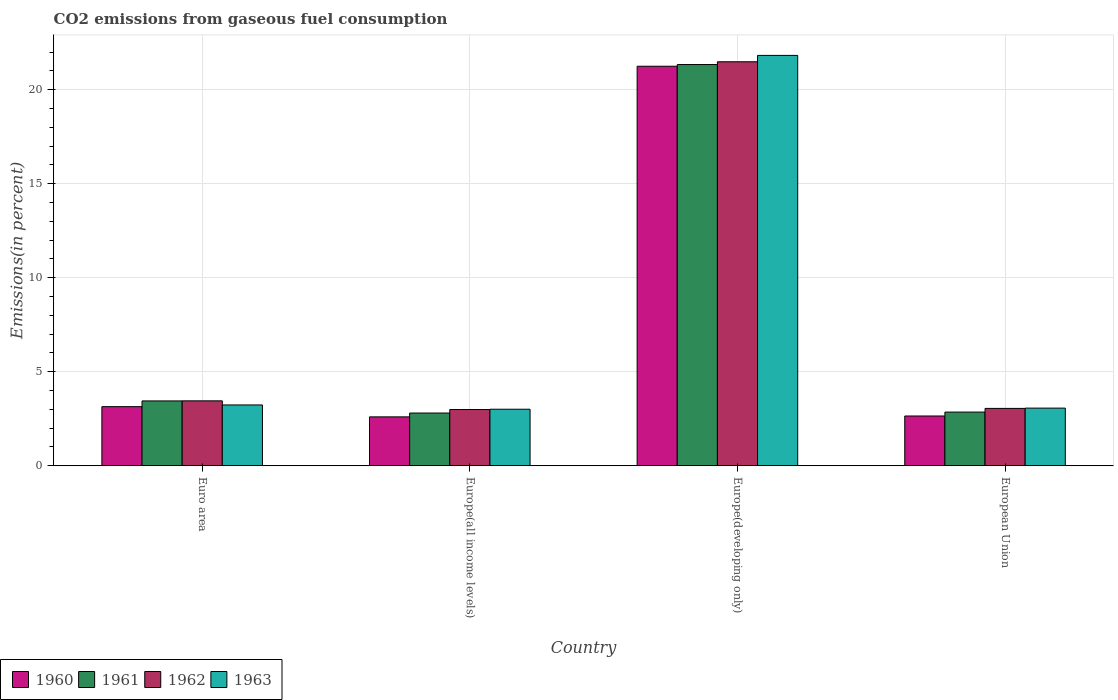Are the number of bars per tick equal to the number of legend labels?
Ensure brevity in your answer.  Yes. What is the label of the 1st group of bars from the left?
Give a very brief answer. Euro area. In how many cases, is the number of bars for a given country not equal to the number of legend labels?
Provide a succinct answer. 0. What is the total CO2 emitted in 1961 in Europe(developing only)?
Your response must be concise. 21.34. Across all countries, what is the maximum total CO2 emitted in 1962?
Provide a short and direct response. 21.49. Across all countries, what is the minimum total CO2 emitted in 1963?
Offer a terse response. 3.01. In which country was the total CO2 emitted in 1963 maximum?
Your answer should be compact. Europe(developing only). In which country was the total CO2 emitted in 1960 minimum?
Your answer should be very brief. Europe(all income levels). What is the total total CO2 emitted in 1962 in the graph?
Your response must be concise. 30.98. What is the difference between the total CO2 emitted in 1962 in Europe(developing only) and that in European Union?
Keep it short and to the point. 18.44. What is the difference between the total CO2 emitted in 1963 in Europe(developing only) and the total CO2 emitted in 1960 in Europe(all income levels)?
Your response must be concise. 19.23. What is the average total CO2 emitted in 1963 per country?
Give a very brief answer. 7.78. What is the difference between the total CO2 emitted of/in 1960 and total CO2 emitted of/in 1963 in Europe(all income levels)?
Ensure brevity in your answer.  -0.41. What is the ratio of the total CO2 emitted in 1963 in Europe(developing only) to that in European Union?
Provide a short and direct response. 7.12. Is the difference between the total CO2 emitted in 1960 in Europe(all income levels) and Europe(developing only) greater than the difference between the total CO2 emitted in 1963 in Europe(all income levels) and Europe(developing only)?
Offer a terse response. Yes. What is the difference between the highest and the second highest total CO2 emitted in 1961?
Give a very brief answer. -0.59. What is the difference between the highest and the lowest total CO2 emitted in 1961?
Keep it short and to the point. 18.54. In how many countries, is the total CO2 emitted in 1960 greater than the average total CO2 emitted in 1960 taken over all countries?
Give a very brief answer. 1. What does the 2nd bar from the right in Europe(all income levels) represents?
Provide a succinct answer. 1962. Does the graph contain any zero values?
Ensure brevity in your answer.  No. Does the graph contain grids?
Your answer should be very brief. Yes. How are the legend labels stacked?
Provide a succinct answer. Horizontal. What is the title of the graph?
Offer a very short reply. CO2 emissions from gaseous fuel consumption. Does "1971" appear as one of the legend labels in the graph?
Keep it short and to the point. No. What is the label or title of the X-axis?
Make the answer very short. Country. What is the label or title of the Y-axis?
Offer a very short reply. Emissions(in percent). What is the Emissions(in percent) of 1960 in Euro area?
Your answer should be very brief. 3.14. What is the Emissions(in percent) in 1961 in Euro area?
Your answer should be very brief. 3.45. What is the Emissions(in percent) of 1962 in Euro area?
Your answer should be very brief. 3.45. What is the Emissions(in percent) of 1963 in Euro area?
Offer a terse response. 3.23. What is the Emissions(in percent) of 1960 in Europe(all income levels)?
Your answer should be very brief. 2.6. What is the Emissions(in percent) in 1961 in Europe(all income levels)?
Offer a very short reply. 2.8. What is the Emissions(in percent) in 1962 in Europe(all income levels)?
Provide a succinct answer. 2.99. What is the Emissions(in percent) of 1963 in Europe(all income levels)?
Keep it short and to the point. 3.01. What is the Emissions(in percent) in 1960 in Europe(developing only)?
Make the answer very short. 21.25. What is the Emissions(in percent) of 1961 in Europe(developing only)?
Give a very brief answer. 21.34. What is the Emissions(in percent) in 1962 in Europe(developing only)?
Your answer should be compact. 21.49. What is the Emissions(in percent) in 1963 in Europe(developing only)?
Your response must be concise. 21.83. What is the Emissions(in percent) of 1960 in European Union?
Give a very brief answer. 2.65. What is the Emissions(in percent) of 1961 in European Union?
Your answer should be compact. 2.85. What is the Emissions(in percent) in 1962 in European Union?
Your response must be concise. 3.05. What is the Emissions(in percent) in 1963 in European Union?
Provide a short and direct response. 3.06. Across all countries, what is the maximum Emissions(in percent) of 1960?
Offer a terse response. 21.25. Across all countries, what is the maximum Emissions(in percent) of 1961?
Offer a terse response. 21.34. Across all countries, what is the maximum Emissions(in percent) in 1962?
Your answer should be very brief. 21.49. Across all countries, what is the maximum Emissions(in percent) of 1963?
Give a very brief answer. 21.83. Across all countries, what is the minimum Emissions(in percent) in 1960?
Your answer should be compact. 2.6. Across all countries, what is the minimum Emissions(in percent) in 1961?
Ensure brevity in your answer.  2.8. Across all countries, what is the minimum Emissions(in percent) of 1962?
Your answer should be very brief. 2.99. Across all countries, what is the minimum Emissions(in percent) in 1963?
Offer a very short reply. 3.01. What is the total Emissions(in percent) in 1960 in the graph?
Offer a very short reply. 29.64. What is the total Emissions(in percent) in 1961 in the graph?
Keep it short and to the point. 30.45. What is the total Emissions(in percent) in 1962 in the graph?
Your response must be concise. 30.98. What is the total Emissions(in percent) of 1963 in the graph?
Offer a terse response. 31.13. What is the difference between the Emissions(in percent) of 1960 in Euro area and that in Europe(all income levels)?
Offer a very short reply. 0.54. What is the difference between the Emissions(in percent) of 1961 in Euro area and that in Europe(all income levels)?
Provide a succinct answer. 0.64. What is the difference between the Emissions(in percent) of 1962 in Euro area and that in Europe(all income levels)?
Your response must be concise. 0.46. What is the difference between the Emissions(in percent) in 1963 in Euro area and that in Europe(all income levels)?
Your response must be concise. 0.23. What is the difference between the Emissions(in percent) of 1960 in Euro area and that in Europe(developing only)?
Your answer should be compact. -18.11. What is the difference between the Emissions(in percent) of 1961 in Euro area and that in Europe(developing only)?
Give a very brief answer. -17.89. What is the difference between the Emissions(in percent) in 1962 in Euro area and that in Europe(developing only)?
Offer a very short reply. -18.04. What is the difference between the Emissions(in percent) in 1963 in Euro area and that in Europe(developing only)?
Offer a very short reply. -18.6. What is the difference between the Emissions(in percent) in 1960 in Euro area and that in European Union?
Offer a very short reply. 0.5. What is the difference between the Emissions(in percent) of 1961 in Euro area and that in European Union?
Your response must be concise. 0.59. What is the difference between the Emissions(in percent) in 1962 in Euro area and that in European Union?
Provide a short and direct response. 0.4. What is the difference between the Emissions(in percent) of 1963 in Euro area and that in European Union?
Offer a very short reply. 0.17. What is the difference between the Emissions(in percent) in 1960 in Europe(all income levels) and that in Europe(developing only)?
Provide a succinct answer. -18.65. What is the difference between the Emissions(in percent) in 1961 in Europe(all income levels) and that in Europe(developing only)?
Provide a short and direct response. -18.54. What is the difference between the Emissions(in percent) of 1962 in Europe(all income levels) and that in Europe(developing only)?
Your answer should be very brief. -18.5. What is the difference between the Emissions(in percent) in 1963 in Europe(all income levels) and that in Europe(developing only)?
Give a very brief answer. -18.82. What is the difference between the Emissions(in percent) of 1960 in Europe(all income levels) and that in European Union?
Provide a short and direct response. -0.05. What is the difference between the Emissions(in percent) in 1961 in Europe(all income levels) and that in European Union?
Give a very brief answer. -0.05. What is the difference between the Emissions(in percent) of 1962 in Europe(all income levels) and that in European Union?
Your answer should be very brief. -0.06. What is the difference between the Emissions(in percent) in 1963 in Europe(all income levels) and that in European Union?
Make the answer very short. -0.06. What is the difference between the Emissions(in percent) in 1960 in Europe(developing only) and that in European Union?
Give a very brief answer. 18.61. What is the difference between the Emissions(in percent) in 1961 in Europe(developing only) and that in European Union?
Offer a terse response. 18.49. What is the difference between the Emissions(in percent) of 1962 in Europe(developing only) and that in European Union?
Provide a short and direct response. 18.44. What is the difference between the Emissions(in percent) of 1963 in Europe(developing only) and that in European Union?
Give a very brief answer. 18.76. What is the difference between the Emissions(in percent) of 1960 in Euro area and the Emissions(in percent) of 1961 in Europe(all income levels)?
Keep it short and to the point. 0.34. What is the difference between the Emissions(in percent) of 1960 in Euro area and the Emissions(in percent) of 1962 in Europe(all income levels)?
Provide a succinct answer. 0.15. What is the difference between the Emissions(in percent) in 1960 in Euro area and the Emissions(in percent) in 1963 in Europe(all income levels)?
Make the answer very short. 0.14. What is the difference between the Emissions(in percent) of 1961 in Euro area and the Emissions(in percent) of 1962 in Europe(all income levels)?
Provide a short and direct response. 0.46. What is the difference between the Emissions(in percent) in 1961 in Euro area and the Emissions(in percent) in 1963 in Europe(all income levels)?
Give a very brief answer. 0.44. What is the difference between the Emissions(in percent) of 1962 in Euro area and the Emissions(in percent) of 1963 in Europe(all income levels)?
Keep it short and to the point. 0.45. What is the difference between the Emissions(in percent) of 1960 in Euro area and the Emissions(in percent) of 1961 in Europe(developing only)?
Your answer should be very brief. -18.2. What is the difference between the Emissions(in percent) of 1960 in Euro area and the Emissions(in percent) of 1962 in Europe(developing only)?
Give a very brief answer. -18.35. What is the difference between the Emissions(in percent) of 1960 in Euro area and the Emissions(in percent) of 1963 in Europe(developing only)?
Make the answer very short. -18.69. What is the difference between the Emissions(in percent) in 1961 in Euro area and the Emissions(in percent) in 1962 in Europe(developing only)?
Give a very brief answer. -18.04. What is the difference between the Emissions(in percent) of 1961 in Euro area and the Emissions(in percent) of 1963 in Europe(developing only)?
Make the answer very short. -18.38. What is the difference between the Emissions(in percent) in 1962 in Euro area and the Emissions(in percent) in 1963 in Europe(developing only)?
Your answer should be very brief. -18.38. What is the difference between the Emissions(in percent) in 1960 in Euro area and the Emissions(in percent) in 1961 in European Union?
Provide a succinct answer. 0.29. What is the difference between the Emissions(in percent) in 1960 in Euro area and the Emissions(in percent) in 1962 in European Union?
Your answer should be compact. 0.09. What is the difference between the Emissions(in percent) of 1960 in Euro area and the Emissions(in percent) of 1963 in European Union?
Your response must be concise. 0.08. What is the difference between the Emissions(in percent) of 1961 in Euro area and the Emissions(in percent) of 1962 in European Union?
Offer a terse response. 0.4. What is the difference between the Emissions(in percent) of 1961 in Euro area and the Emissions(in percent) of 1963 in European Union?
Provide a short and direct response. 0.38. What is the difference between the Emissions(in percent) of 1962 in Euro area and the Emissions(in percent) of 1963 in European Union?
Keep it short and to the point. 0.39. What is the difference between the Emissions(in percent) of 1960 in Europe(all income levels) and the Emissions(in percent) of 1961 in Europe(developing only)?
Give a very brief answer. -18.74. What is the difference between the Emissions(in percent) in 1960 in Europe(all income levels) and the Emissions(in percent) in 1962 in Europe(developing only)?
Keep it short and to the point. -18.89. What is the difference between the Emissions(in percent) in 1960 in Europe(all income levels) and the Emissions(in percent) in 1963 in Europe(developing only)?
Provide a short and direct response. -19.23. What is the difference between the Emissions(in percent) in 1961 in Europe(all income levels) and the Emissions(in percent) in 1962 in Europe(developing only)?
Offer a terse response. -18.69. What is the difference between the Emissions(in percent) of 1961 in Europe(all income levels) and the Emissions(in percent) of 1963 in Europe(developing only)?
Keep it short and to the point. -19.03. What is the difference between the Emissions(in percent) of 1962 in Europe(all income levels) and the Emissions(in percent) of 1963 in Europe(developing only)?
Your answer should be very brief. -18.84. What is the difference between the Emissions(in percent) of 1960 in Europe(all income levels) and the Emissions(in percent) of 1961 in European Union?
Keep it short and to the point. -0.25. What is the difference between the Emissions(in percent) of 1960 in Europe(all income levels) and the Emissions(in percent) of 1962 in European Union?
Provide a short and direct response. -0.45. What is the difference between the Emissions(in percent) in 1960 in Europe(all income levels) and the Emissions(in percent) in 1963 in European Union?
Keep it short and to the point. -0.47. What is the difference between the Emissions(in percent) in 1961 in Europe(all income levels) and the Emissions(in percent) in 1962 in European Union?
Ensure brevity in your answer.  -0.25. What is the difference between the Emissions(in percent) in 1961 in Europe(all income levels) and the Emissions(in percent) in 1963 in European Union?
Keep it short and to the point. -0.26. What is the difference between the Emissions(in percent) of 1962 in Europe(all income levels) and the Emissions(in percent) of 1963 in European Union?
Give a very brief answer. -0.07. What is the difference between the Emissions(in percent) in 1960 in Europe(developing only) and the Emissions(in percent) in 1961 in European Union?
Your answer should be very brief. 18.4. What is the difference between the Emissions(in percent) of 1960 in Europe(developing only) and the Emissions(in percent) of 1962 in European Union?
Provide a succinct answer. 18.2. What is the difference between the Emissions(in percent) in 1960 in Europe(developing only) and the Emissions(in percent) in 1963 in European Union?
Offer a terse response. 18.19. What is the difference between the Emissions(in percent) in 1961 in Europe(developing only) and the Emissions(in percent) in 1962 in European Union?
Keep it short and to the point. 18.29. What is the difference between the Emissions(in percent) in 1961 in Europe(developing only) and the Emissions(in percent) in 1963 in European Union?
Keep it short and to the point. 18.28. What is the difference between the Emissions(in percent) of 1962 in Europe(developing only) and the Emissions(in percent) of 1963 in European Union?
Keep it short and to the point. 18.43. What is the average Emissions(in percent) in 1960 per country?
Offer a terse response. 7.41. What is the average Emissions(in percent) of 1961 per country?
Your answer should be compact. 7.61. What is the average Emissions(in percent) of 1962 per country?
Make the answer very short. 7.75. What is the average Emissions(in percent) of 1963 per country?
Offer a terse response. 7.78. What is the difference between the Emissions(in percent) in 1960 and Emissions(in percent) in 1961 in Euro area?
Provide a short and direct response. -0.3. What is the difference between the Emissions(in percent) in 1960 and Emissions(in percent) in 1962 in Euro area?
Your answer should be compact. -0.31. What is the difference between the Emissions(in percent) of 1960 and Emissions(in percent) of 1963 in Euro area?
Your answer should be compact. -0.09. What is the difference between the Emissions(in percent) of 1961 and Emissions(in percent) of 1962 in Euro area?
Offer a very short reply. -0. What is the difference between the Emissions(in percent) in 1961 and Emissions(in percent) in 1963 in Euro area?
Give a very brief answer. 0.21. What is the difference between the Emissions(in percent) in 1962 and Emissions(in percent) in 1963 in Euro area?
Keep it short and to the point. 0.22. What is the difference between the Emissions(in percent) of 1960 and Emissions(in percent) of 1961 in Europe(all income levels)?
Provide a short and direct response. -0.2. What is the difference between the Emissions(in percent) in 1960 and Emissions(in percent) in 1962 in Europe(all income levels)?
Offer a very short reply. -0.39. What is the difference between the Emissions(in percent) in 1960 and Emissions(in percent) in 1963 in Europe(all income levels)?
Offer a very short reply. -0.41. What is the difference between the Emissions(in percent) in 1961 and Emissions(in percent) in 1962 in Europe(all income levels)?
Your response must be concise. -0.19. What is the difference between the Emissions(in percent) of 1961 and Emissions(in percent) of 1963 in Europe(all income levels)?
Give a very brief answer. -0.2. What is the difference between the Emissions(in percent) of 1962 and Emissions(in percent) of 1963 in Europe(all income levels)?
Keep it short and to the point. -0.02. What is the difference between the Emissions(in percent) of 1960 and Emissions(in percent) of 1961 in Europe(developing only)?
Your response must be concise. -0.09. What is the difference between the Emissions(in percent) of 1960 and Emissions(in percent) of 1962 in Europe(developing only)?
Your answer should be compact. -0.24. What is the difference between the Emissions(in percent) of 1960 and Emissions(in percent) of 1963 in Europe(developing only)?
Your answer should be very brief. -0.58. What is the difference between the Emissions(in percent) in 1961 and Emissions(in percent) in 1962 in Europe(developing only)?
Give a very brief answer. -0.15. What is the difference between the Emissions(in percent) in 1961 and Emissions(in percent) in 1963 in Europe(developing only)?
Your response must be concise. -0.49. What is the difference between the Emissions(in percent) of 1962 and Emissions(in percent) of 1963 in Europe(developing only)?
Provide a succinct answer. -0.34. What is the difference between the Emissions(in percent) in 1960 and Emissions(in percent) in 1961 in European Union?
Give a very brief answer. -0.21. What is the difference between the Emissions(in percent) in 1960 and Emissions(in percent) in 1962 in European Union?
Keep it short and to the point. -0.4. What is the difference between the Emissions(in percent) in 1960 and Emissions(in percent) in 1963 in European Union?
Your answer should be very brief. -0.42. What is the difference between the Emissions(in percent) in 1961 and Emissions(in percent) in 1962 in European Union?
Provide a succinct answer. -0.2. What is the difference between the Emissions(in percent) in 1961 and Emissions(in percent) in 1963 in European Union?
Provide a succinct answer. -0.21. What is the difference between the Emissions(in percent) of 1962 and Emissions(in percent) of 1963 in European Union?
Your answer should be compact. -0.01. What is the ratio of the Emissions(in percent) in 1960 in Euro area to that in Europe(all income levels)?
Provide a short and direct response. 1.21. What is the ratio of the Emissions(in percent) of 1961 in Euro area to that in Europe(all income levels)?
Offer a very short reply. 1.23. What is the ratio of the Emissions(in percent) in 1962 in Euro area to that in Europe(all income levels)?
Your answer should be compact. 1.15. What is the ratio of the Emissions(in percent) of 1963 in Euro area to that in Europe(all income levels)?
Ensure brevity in your answer.  1.08. What is the ratio of the Emissions(in percent) of 1960 in Euro area to that in Europe(developing only)?
Make the answer very short. 0.15. What is the ratio of the Emissions(in percent) in 1961 in Euro area to that in Europe(developing only)?
Provide a succinct answer. 0.16. What is the ratio of the Emissions(in percent) of 1962 in Euro area to that in Europe(developing only)?
Keep it short and to the point. 0.16. What is the ratio of the Emissions(in percent) of 1963 in Euro area to that in Europe(developing only)?
Provide a succinct answer. 0.15. What is the ratio of the Emissions(in percent) in 1960 in Euro area to that in European Union?
Provide a short and direct response. 1.19. What is the ratio of the Emissions(in percent) in 1961 in Euro area to that in European Union?
Offer a terse response. 1.21. What is the ratio of the Emissions(in percent) in 1962 in Euro area to that in European Union?
Provide a succinct answer. 1.13. What is the ratio of the Emissions(in percent) in 1963 in Euro area to that in European Union?
Give a very brief answer. 1.06. What is the ratio of the Emissions(in percent) in 1960 in Europe(all income levels) to that in Europe(developing only)?
Ensure brevity in your answer.  0.12. What is the ratio of the Emissions(in percent) of 1961 in Europe(all income levels) to that in Europe(developing only)?
Your answer should be very brief. 0.13. What is the ratio of the Emissions(in percent) in 1962 in Europe(all income levels) to that in Europe(developing only)?
Your response must be concise. 0.14. What is the ratio of the Emissions(in percent) in 1963 in Europe(all income levels) to that in Europe(developing only)?
Provide a succinct answer. 0.14. What is the ratio of the Emissions(in percent) of 1960 in Europe(all income levels) to that in European Union?
Keep it short and to the point. 0.98. What is the ratio of the Emissions(in percent) in 1961 in Europe(all income levels) to that in European Union?
Your answer should be compact. 0.98. What is the ratio of the Emissions(in percent) of 1962 in Europe(all income levels) to that in European Union?
Your answer should be very brief. 0.98. What is the ratio of the Emissions(in percent) of 1963 in Europe(all income levels) to that in European Union?
Provide a succinct answer. 0.98. What is the ratio of the Emissions(in percent) of 1960 in Europe(developing only) to that in European Union?
Offer a terse response. 8.03. What is the ratio of the Emissions(in percent) in 1961 in Europe(developing only) to that in European Union?
Make the answer very short. 7.48. What is the ratio of the Emissions(in percent) of 1962 in Europe(developing only) to that in European Union?
Keep it short and to the point. 7.05. What is the ratio of the Emissions(in percent) in 1963 in Europe(developing only) to that in European Union?
Offer a terse response. 7.12. What is the difference between the highest and the second highest Emissions(in percent) in 1960?
Offer a very short reply. 18.11. What is the difference between the highest and the second highest Emissions(in percent) of 1961?
Your answer should be very brief. 17.89. What is the difference between the highest and the second highest Emissions(in percent) in 1962?
Your response must be concise. 18.04. What is the difference between the highest and the second highest Emissions(in percent) of 1963?
Give a very brief answer. 18.6. What is the difference between the highest and the lowest Emissions(in percent) in 1960?
Your answer should be compact. 18.65. What is the difference between the highest and the lowest Emissions(in percent) in 1961?
Provide a short and direct response. 18.54. What is the difference between the highest and the lowest Emissions(in percent) of 1962?
Give a very brief answer. 18.5. What is the difference between the highest and the lowest Emissions(in percent) of 1963?
Offer a very short reply. 18.82. 